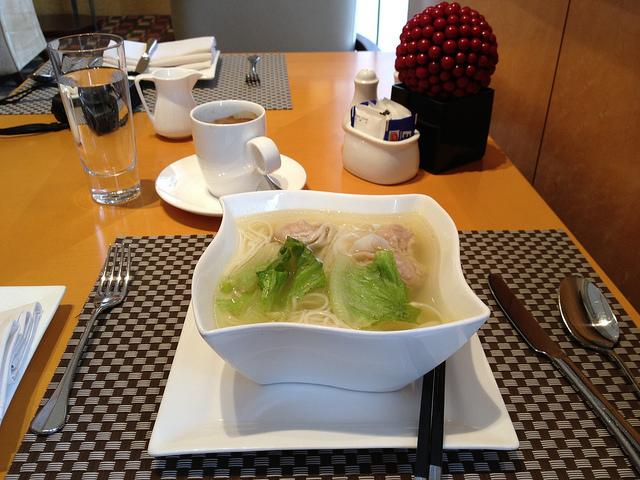Do you need a knife to eat the Pho?
Give a very brief answer. No. Could the soup be Pho?
Concise answer only. Yes. What utensils are sitting on the plate?
Concise answer only. Chopsticks. 